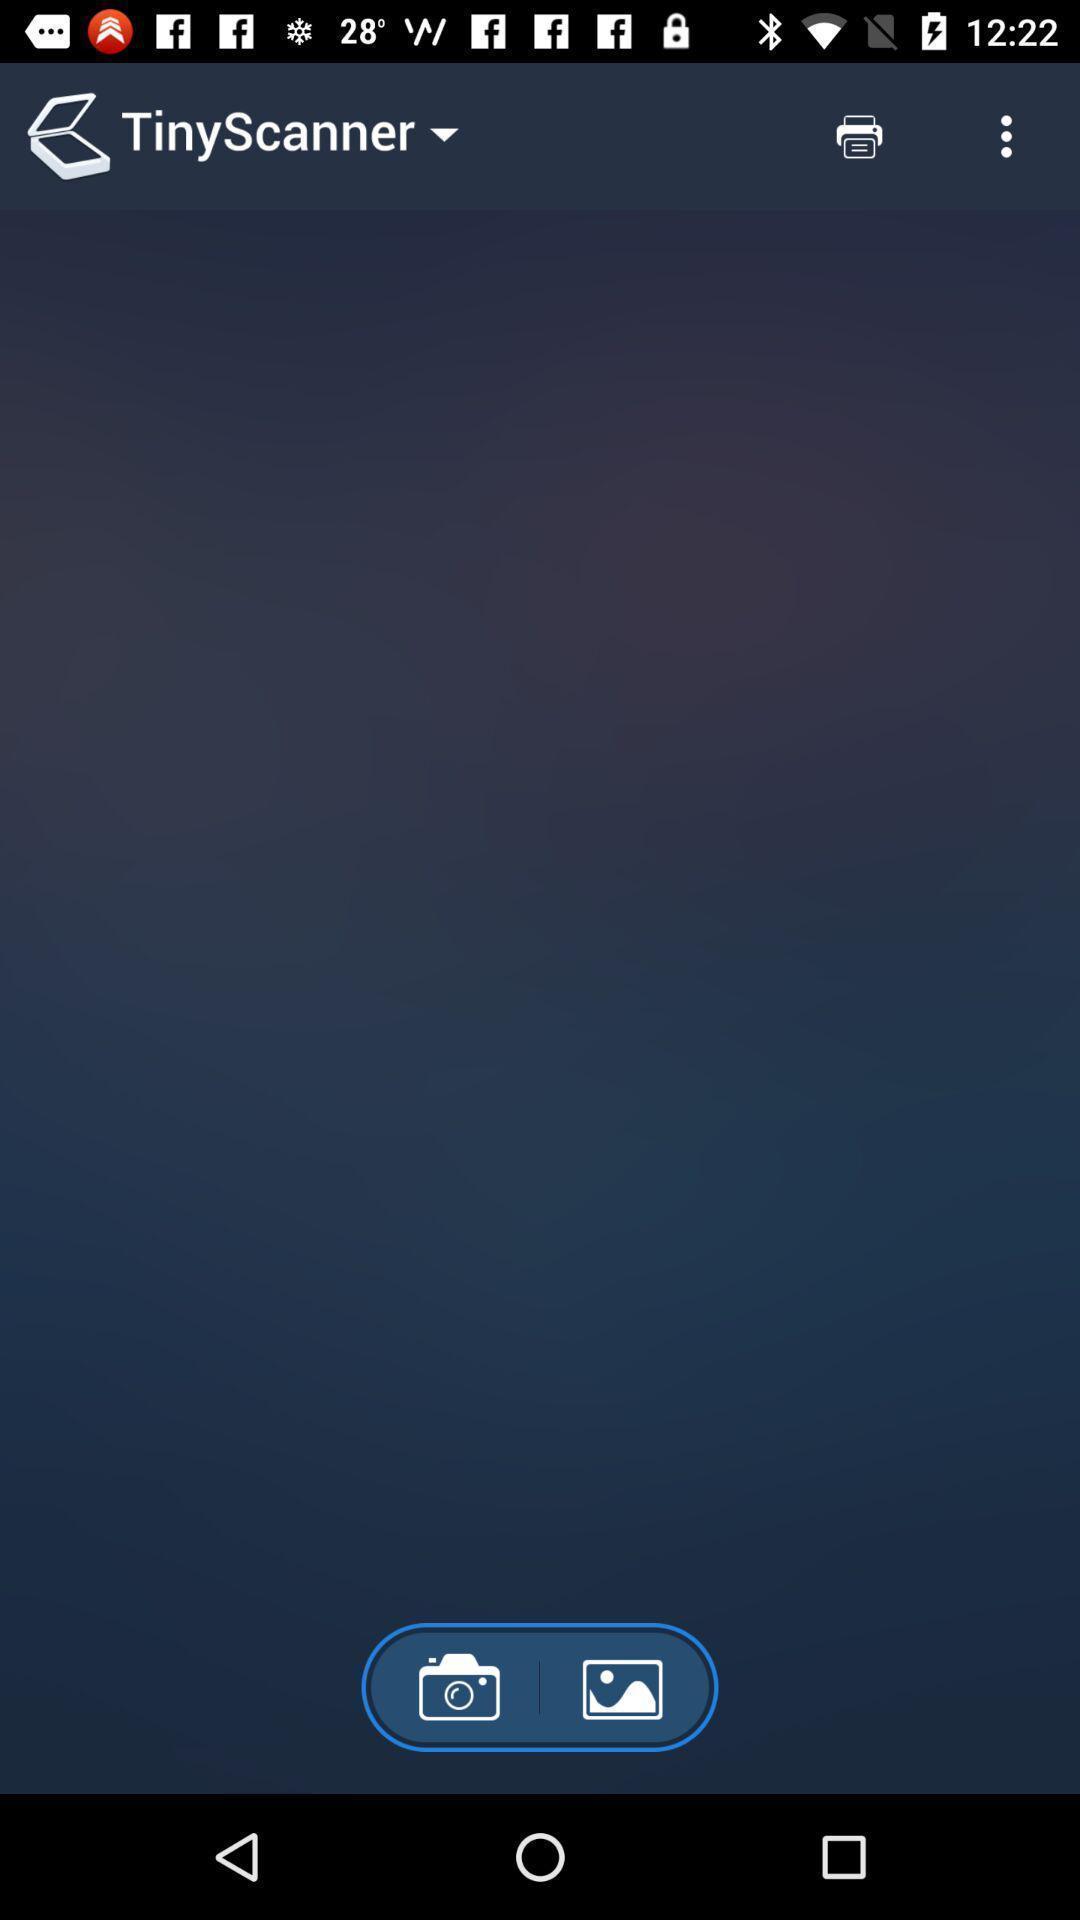Tell me what you see in this picture. Screen showing camera and photo options. 